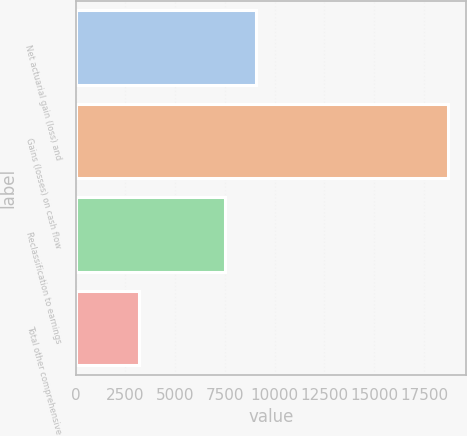Convert chart. <chart><loc_0><loc_0><loc_500><loc_500><bar_chart><fcel>Net actuarial gain (loss) and<fcel>Gains (losses) on cash flow<fcel>Reclassification to earnings<fcel>Total other comprehensive<nl><fcel>9073.7<fcel>18701<fcel>7524<fcel>3204<nl></chart> 